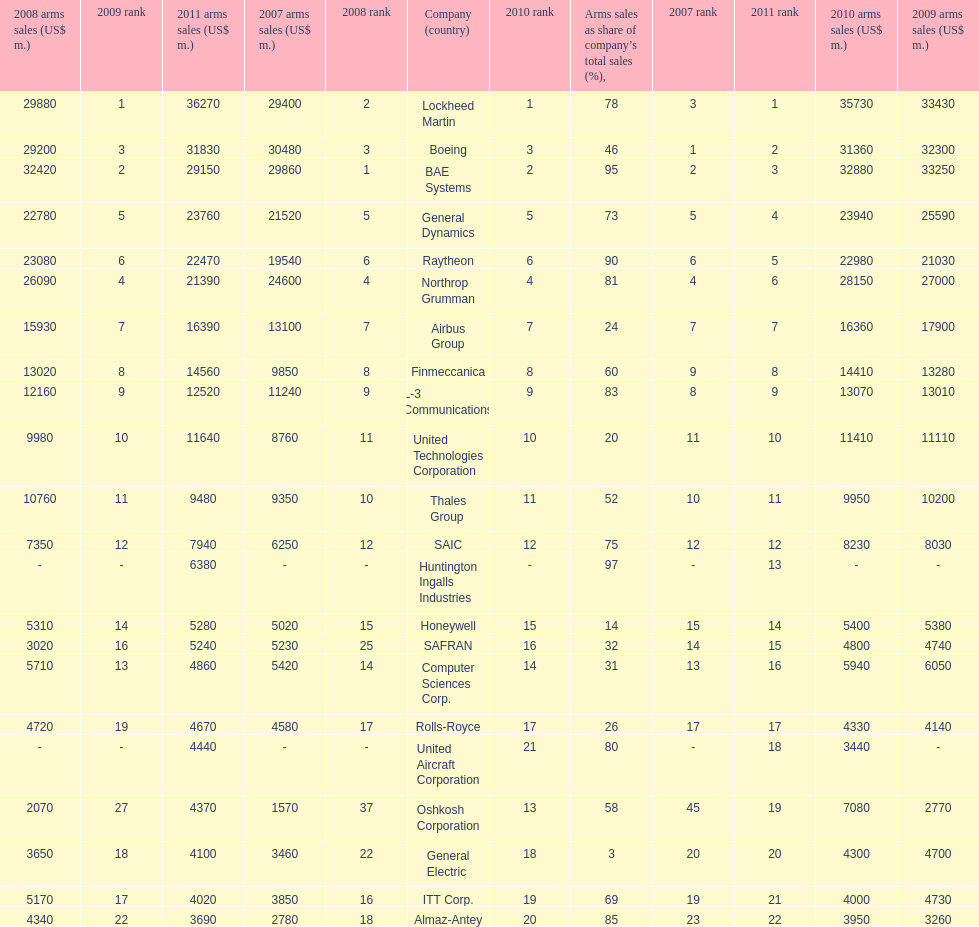What country is the first listed country? USA. 